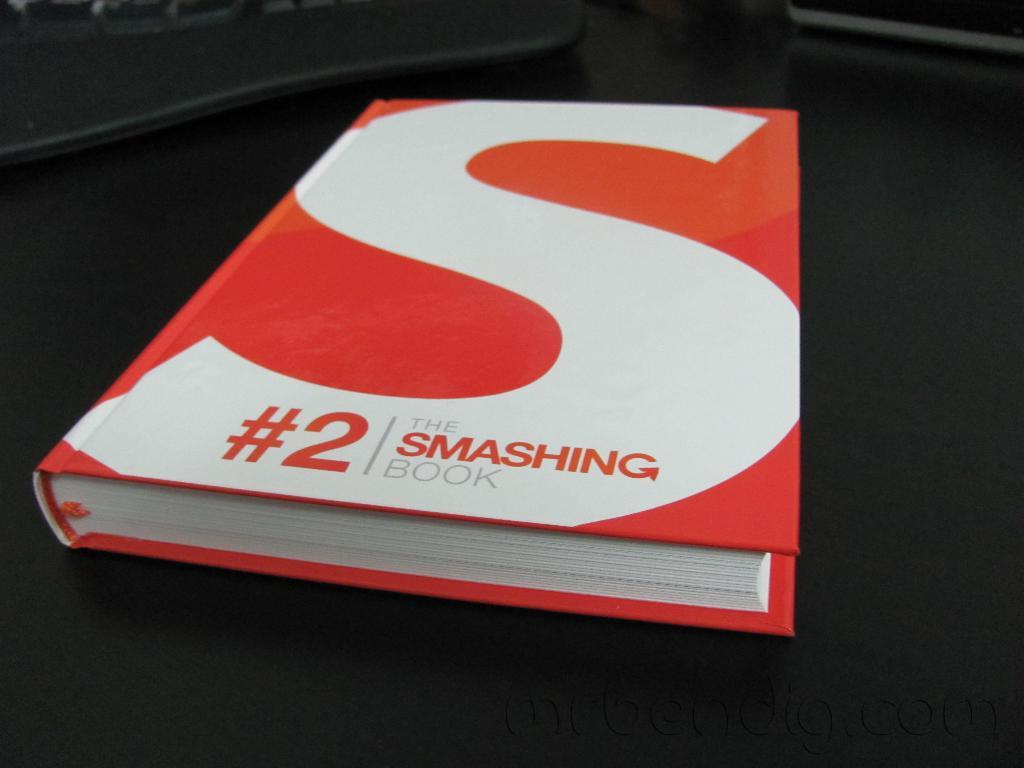<image>
Write a terse but informative summary of the picture. a red and white book with the word smashing on it 